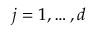<formula> <loc_0><loc_0><loc_500><loc_500>j = 1 , \dots , d</formula> 